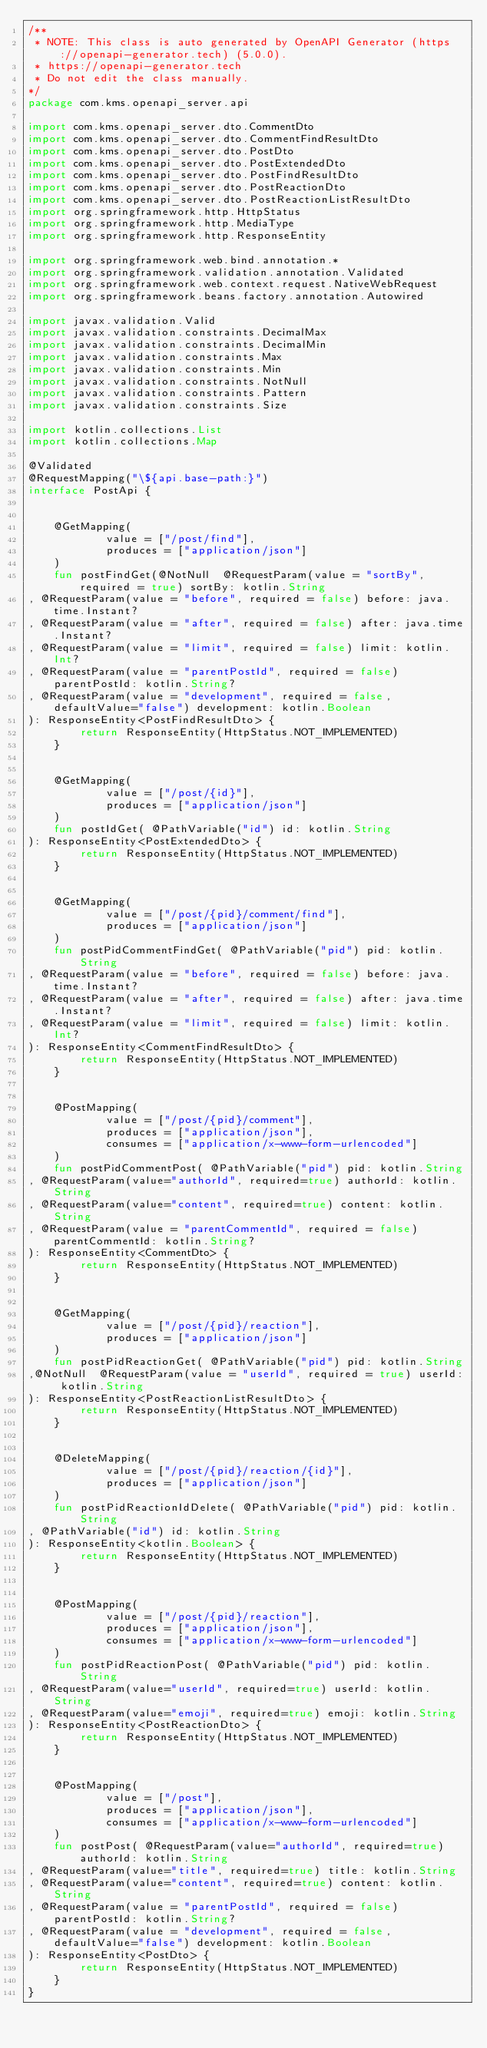Convert code to text. <code><loc_0><loc_0><loc_500><loc_500><_Kotlin_>/**
 * NOTE: This class is auto generated by OpenAPI Generator (https://openapi-generator.tech) (5.0.0).
 * https://openapi-generator.tech
 * Do not edit the class manually.
*/
package com.kms.openapi_server.api

import com.kms.openapi_server.dto.CommentDto
import com.kms.openapi_server.dto.CommentFindResultDto
import com.kms.openapi_server.dto.PostDto
import com.kms.openapi_server.dto.PostExtendedDto
import com.kms.openapi_server.dto.PostFindResultDto
import com.kms.openapi_server.dto.PostReactionDto
import com.kms.openapi_server.dto.PostReactionListResultDto
import org.springframework.http.HttpStatus
import org.springframework.http.MediaType
import org.springframework.http.ResponseEntity

import org.springframework.web.bind.annotation.*
import org.springframework.validation.annotation.Validated
import org.springframework.web.context.request.NativeWebRequest
import org.springframework.beans.factory.annotation.Autowired

import javax.validation.Valid
import javax.validation.constraints.DecimalMax
import javax.validation.constraints.DecimalMin
import javax.validation.constraints.Max
import javax.validation.constraints.Min
import javax.validation.constraints.NotNull
import javax.validation.constraints.Pattern
import javax.validation.constraints.Size

import kotlin.collections.List
import kotlin.collections.Map

@Validated
@RequestMapping("\${api.base-path:}")
interface PostApi {


    @GetMapping(
            value = ["/post/find"],
            produces = ["application/json"]
    )
    fun postFindGet(@NotNull  @RequestParam(value = "sortBy", required = true) sortBy: kotlin.String
, @RequestParam(value = "before", required = false) before: java.time.Instant?
, @RequestParam(value = "after", required = false) after: java.time.Instant?
, @RequestParam(value = "limit", required = false) limit: kotlin.Int?
, @RequestParam(value = "parentPostId", required = false) parentPostId: kotlin.String?
, @RequestParam(value = "development", required = false, defaultValue="false") development: kotlin.Boolean
): ResponseEntity<PostFindResultDto> {
        return ResponseEntity(HttpStatus.NOT_IMPLEMENTED)
    }


    @GetMapping(
            value = ["/post/{id}"],
            produces = ["application/json"]
    )
    fun postIdGet( @PathVariable("id") id: kotlin.String
): ResponseEntity<PostExtendedDto> {
        return ResponseEntity(HttpStatus.NOT_IMPLEMENTED)
    }


    @GetMapping(
            value = ["/post/{pid}/comment/find"],
            produces = ["application/json"]
    )
    fun postPidCommentFindGet( @PathVariable("pid") pid: kotlin.String
, @RequestParam(value = "before", required = false) before: java.time.Instant?
, @RequestParam(value = "after", required = false) after: java.time.Instant?
, @RequestParam(value = "limit", required = false) limit: kotlin.Int?
): ResponseEntity<CommentFindResultDto> {
        return ResponseEntity(HttpStatus.NOT_IMPLEMENTED)
    }


    @PostMapping(
            value = ["/post/{pid}/comment"],
            produces = ["application/json"],
            consumes = ["application/x-www-form-urlencoded"]
    )
    fun postPidCommentPost( @PathVariable("pid") pid: kotlin.String
, @RequestParam(value="authorId", required=true) authorId: kotlin.String 
, @RequestParam(value="content", required=true) content: kotlin.String 
, @RequestParam(value = "parentCommentId", required = false) parentCommentId: kotlin.String?
): ResponseEntity<CommentDto> {
        return ResponseEntity(HttpStatus.NOT_IMPLEMENTED)
    }


    @GetMapping(
            value = ["/post/{pid}/reaction"],
            produces = ["application/json"]
    )
    fun postPidReactionGet( @PathVariable("pid") pid: kotlin.String
,@NotNull  @RequestParam(value = "userId", required = true) userId: kotlin.String
): ResponseEntity<PostReactionListResultDto> {
        return ResponseEntity(HttpStatus.NOT_IMPLEMENTED)
    }


    @DeleteMapping(
            value = ["/post/{pid}/reaction/{id}"],
            produces = ["application/json"]
    )
    fun postPidReactionIdDelete( @PathVariable("pid") pid: kotlin.String
, @PathVariable("id") id: kotlin.String
): ResponseEntity<kotlin.Boolean> {
        return ResponseEntity(HttpStatus.NOT_IMPLEMENTED)
    }


    @PostMapping(
            value = ["/post/{pid}/reaction"],
            produces = ["application/json"],
            consumes = ["application/x-www-form-urlencoded"]
    )
    fun postPidReactionPost( @PathVariable("pid") pid: kotlin.String
, @RequestParam(value="userId", required=true) userId: kotlin.String 
, @RequestParam(value="emoji", required=true) emoji: kotlin.String 
): ResponseEntity<PostReactionDto> {
        return ResponseEntity(HttpStatus.NOT_IMPLEMENTED)
    }


    @PostMapping(
            value = ["/post"],
            produces = ["application/json"],
            consumes = ["application/x-www-form-urlencoded"]
    )
    fun postPost( @RequestParam(value="authorId", required=true) authorId: kotlin.String 
, @RequestParam(value="title", required=true) title: kotlin.String 
, @RequestParam(value="content", required=true) content: kotlin.String 
, @RequestParam(value = "parentPostId", required = false) parentPostId: kotlin.String?
, @RequestParam(value = "development", required = false, defaultValue="false") development: kotlin.Boolean
): ResponseEntity<PostDto> {
        return ResponseEntity(HttpStatus.NOT_IMPLEMENTED)
    }
}
</code> 